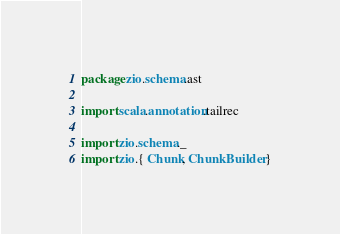<code> <loc_0><loc_0><loc_500><loc_500><_Scala_>package zio.schema.ast

import scala.annotation.tailrec

import zio.schema._
import zio.{ Chunk, ChunkBuilder }
</code> 